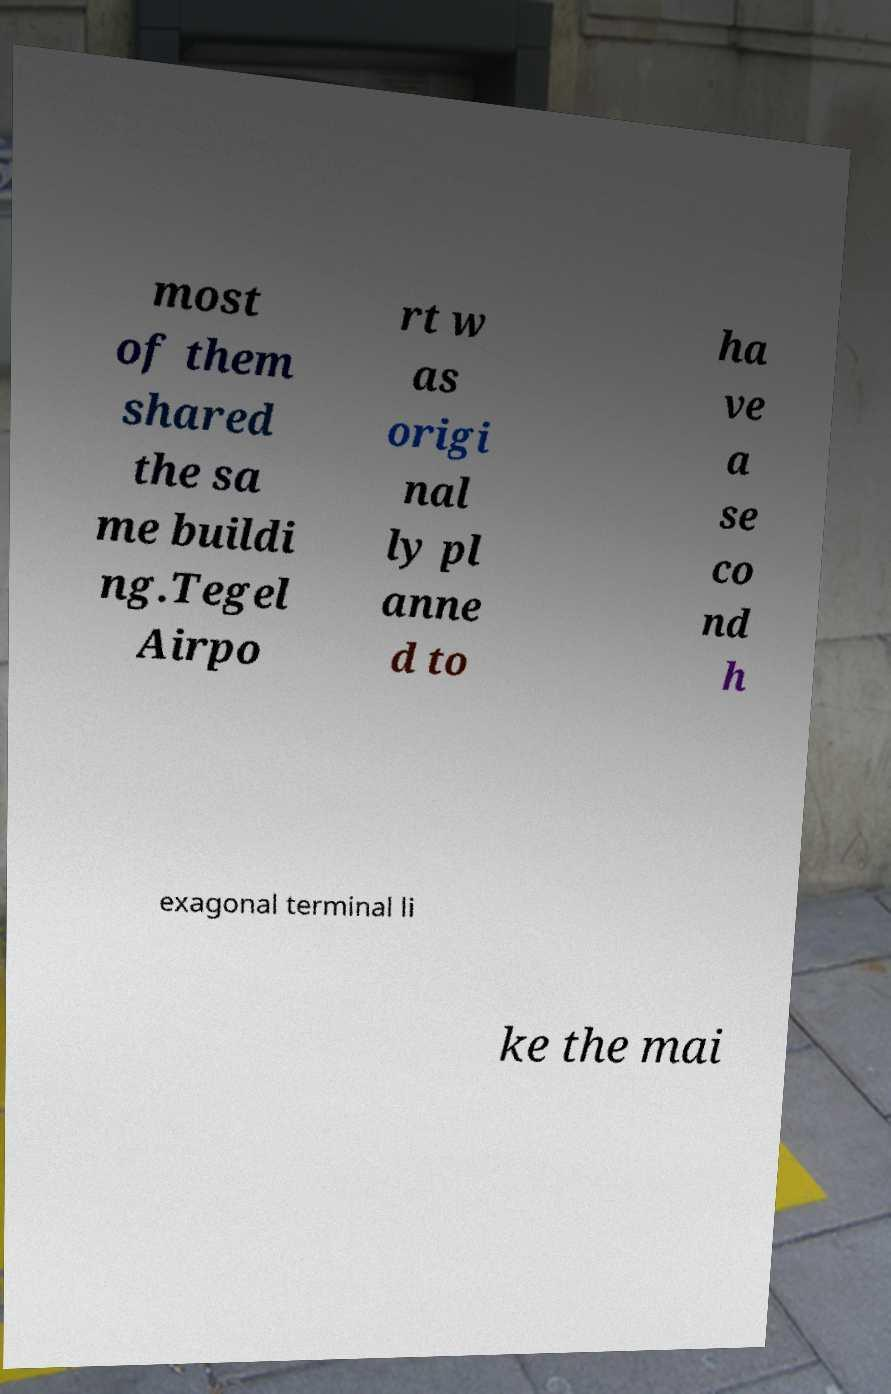Could you extract and type out the text from this image? most of them shared the sa me buildi ng.Tegel Airpo rt w as origi nal ly pl anne d to ha ve a se co nd h exagonal terminal li ke the mai 